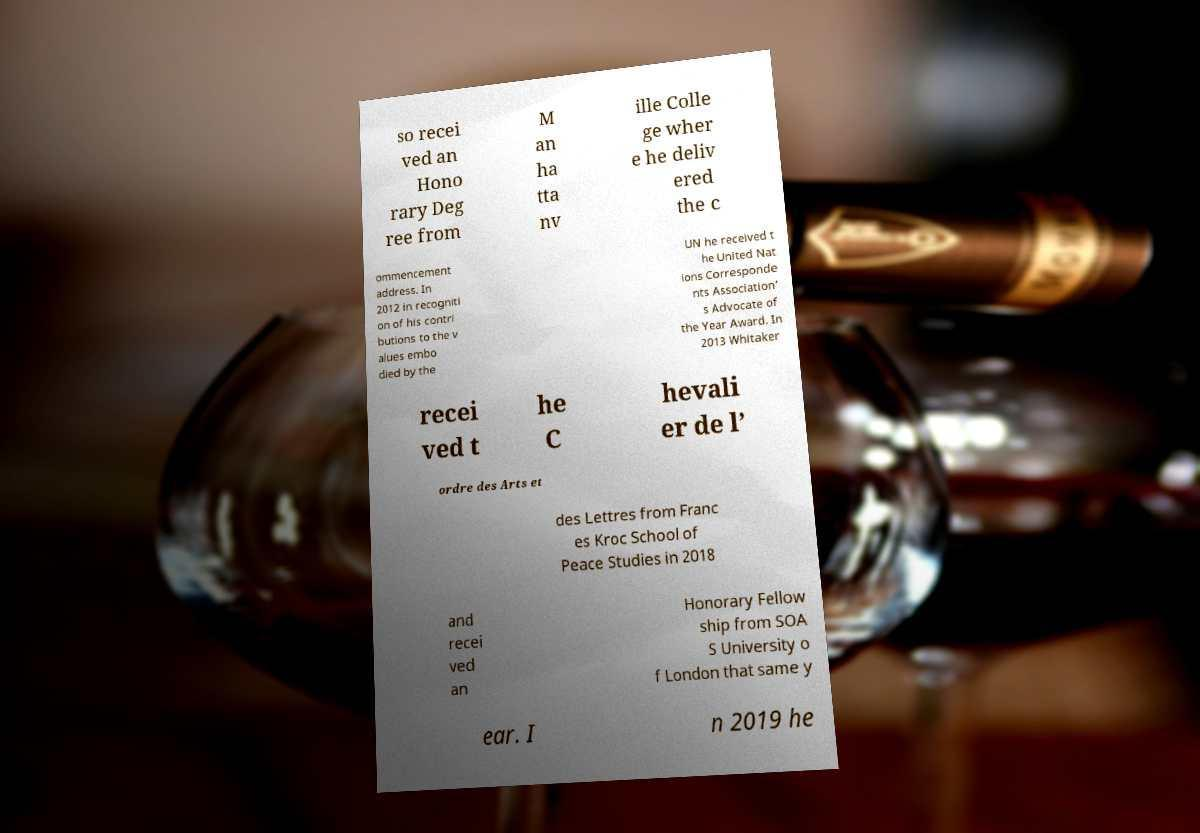There's text embedded in this image that I need extracted. Can you transcribe it verbatim? so recei ved an Hono rary Deg ree from M an ha tta nv ille Colle ge wher e he deliv ered the c ommencement address. In 2012 in recogniti on of his contri butions to the v alues embo died by the UN he received t he United Nat ions Corresponde nts Association’ s Advocate of the Year Award. In 2013 Whitaker recei ved t he C hevali er de l’ ordre des Arts et des Lettres from Franc es Kroc School of Peace Studies in 2018 and recei ved an Honorary Fellow ship from SOA S University o f London that same y ear. I n 2019 he 